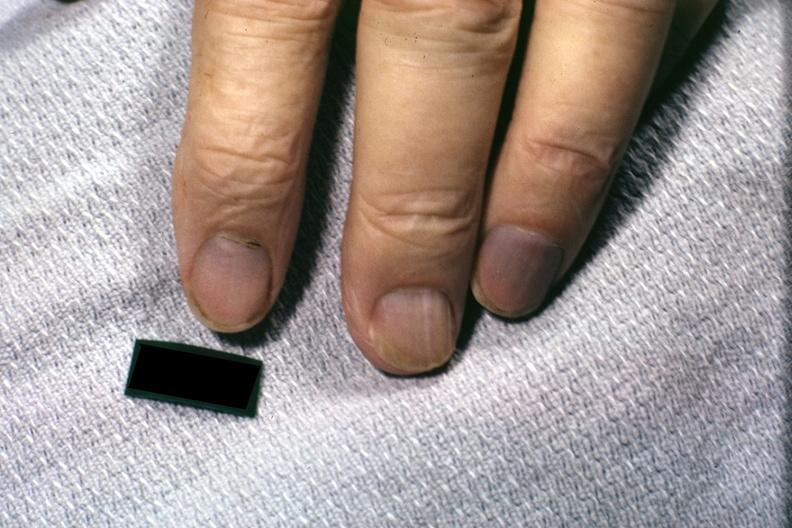what is present?
Answer the question using a single word or phrase. Acrocyanosis 